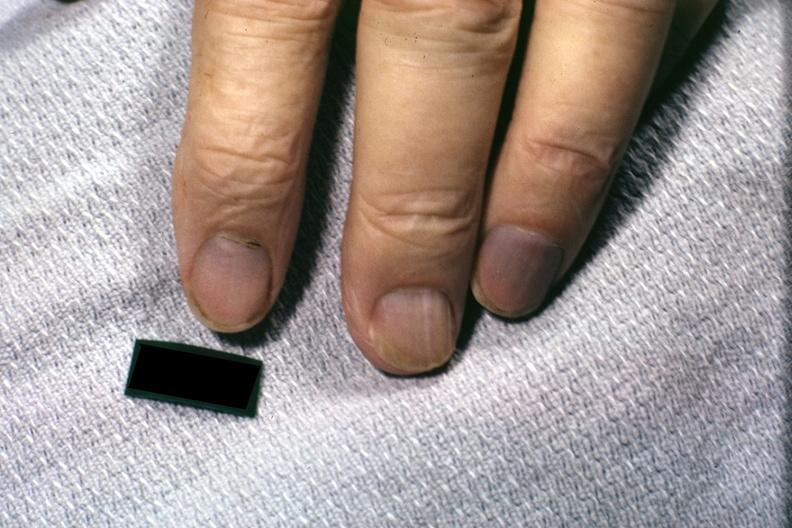what is present?
Answer the question using a single word or phrase. Acrocyanosis 